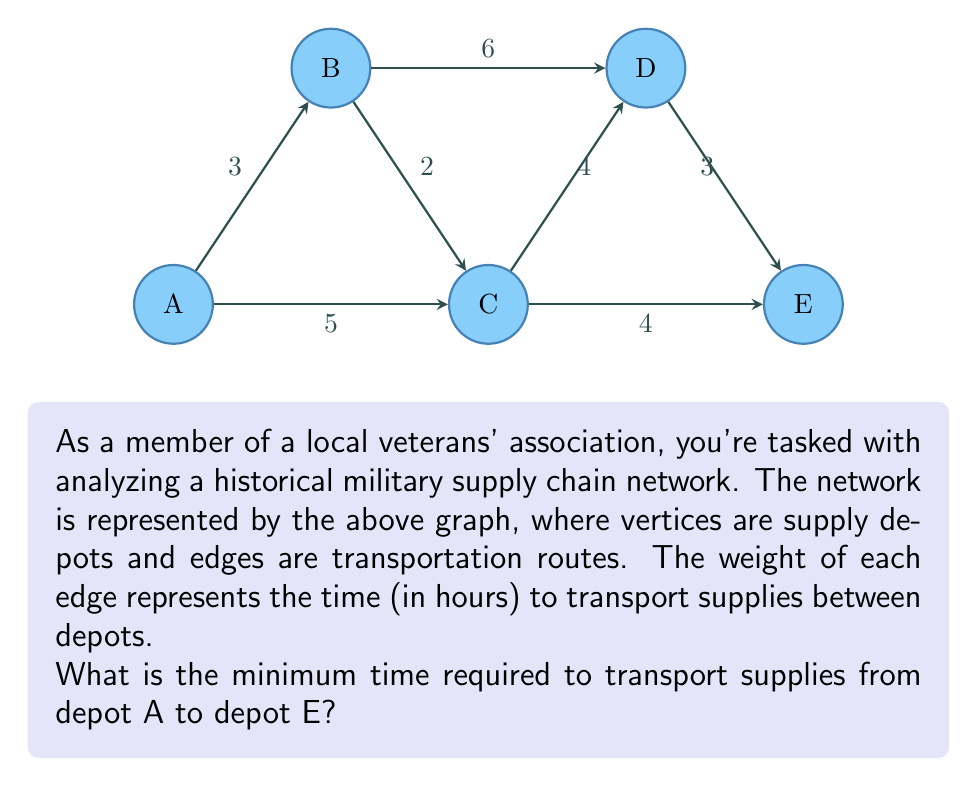Provide a solution to this math problem. To solve this problem, we need to find the shortest path from A to E in the given graph. We can use Dijkstra's algorithm or simply examine all possible paths:

1. Possible paths from A to E:
   a) A → B → C → D → E
   b) A → B → D → E
   c) A → C → D → E
   d) A → C → E

2. Calculate the total time for each path:
   a) A → B → C → D → E: $3 + 2 + 4 + 3 = 12$ hours
   b) A → B → D → E: $3 + 6 + 3 = 12$ hours
   c) A → C → D → E: $5 + 4 + 3 = 12$ hours
   d) A → C → E: $5 + 4 = 9$ hours

3. Comparing the total times:
   Path (d) A → C → E has the minimum time of 9 hours.

Therefore, the minimum time required to transport supplies from depot A to depot E is 9 hours.
Answer: 9 hours 